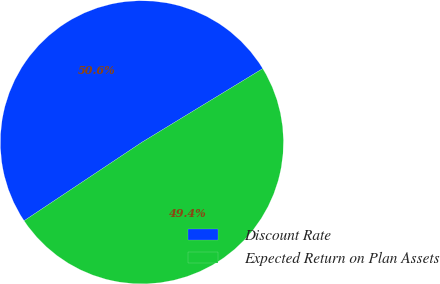<chart> <loc_0><loc_0><loc_500><loc_500><pie_chart><fcel>Discount Rate<fcel>Expected Return on Plan Assets<nl><fcel>50.64%<fcel>49.36%<nl></chart> 